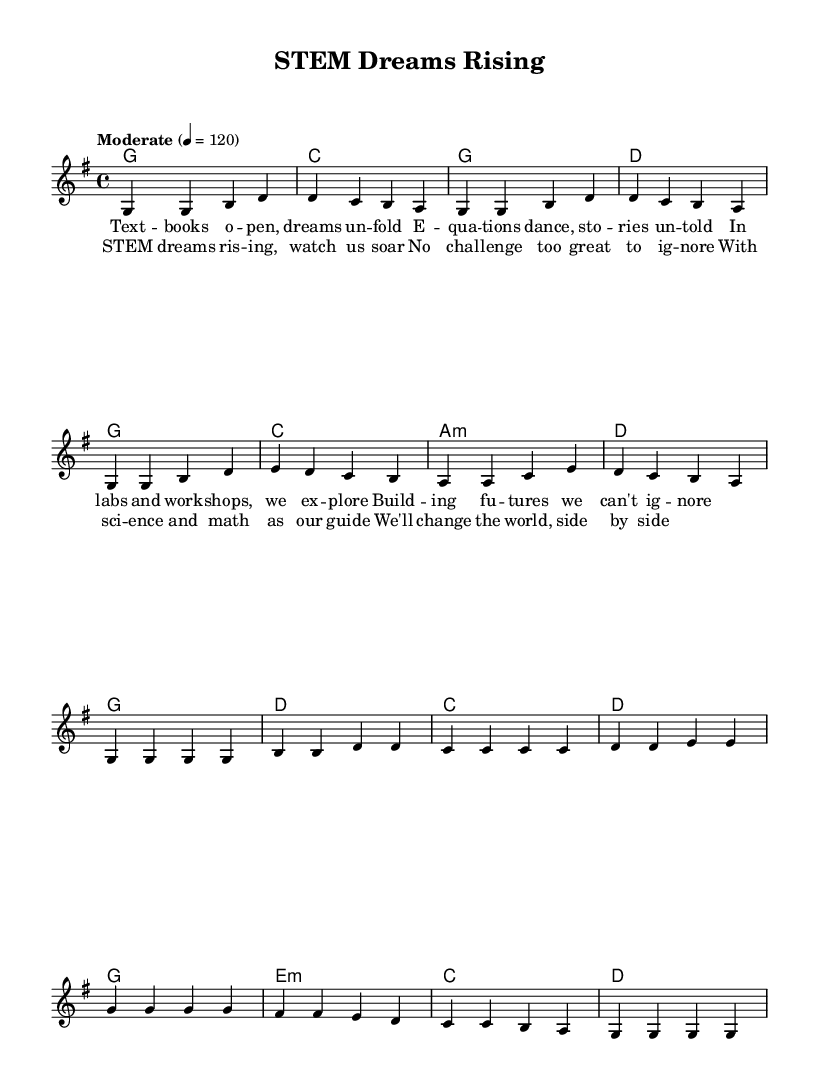What is the key signature of this music? The key signature is G major, indicated by one sharp (F#) in the sheet music.
Answer: G major What is the time signature of this piece? The time signature is 4/4, shown at the beginning of the sheet music as a standard time signature.
Answer: 4/4 What is the tempo marking for this piece? The tempo marking is "Moderate" with a speed of 120 beats per minute, indicating a moderate pace for the performance.
Answer: Moderate, 120 How many measures are in the verse section? The verse section contains 8 measures, as seen by counting each grouped set of notes in that section.
Answer: 8 What is the first lyric of the chorus? The first lyric of the chorus is "STEM dreams rising," which begins the thematic shift from the verse to the chorus.
Answer: STEM dreams rising What is the harmonic progression at the end of the chorus? The harmonic progression at the end of the chorus is G to E minor to C to D, which supports the final lyrical lines and creates resolution.
Answer: G, E minor, C, D Why is this piece characterized as a Folk song? This piece can be characterized as a Folk song due to its simple melody, repetitive structure, and themes centered around personal and collective experiences, common in Folk music traditions.
Answer: Simple melody, repetitive structure, and collective themes 